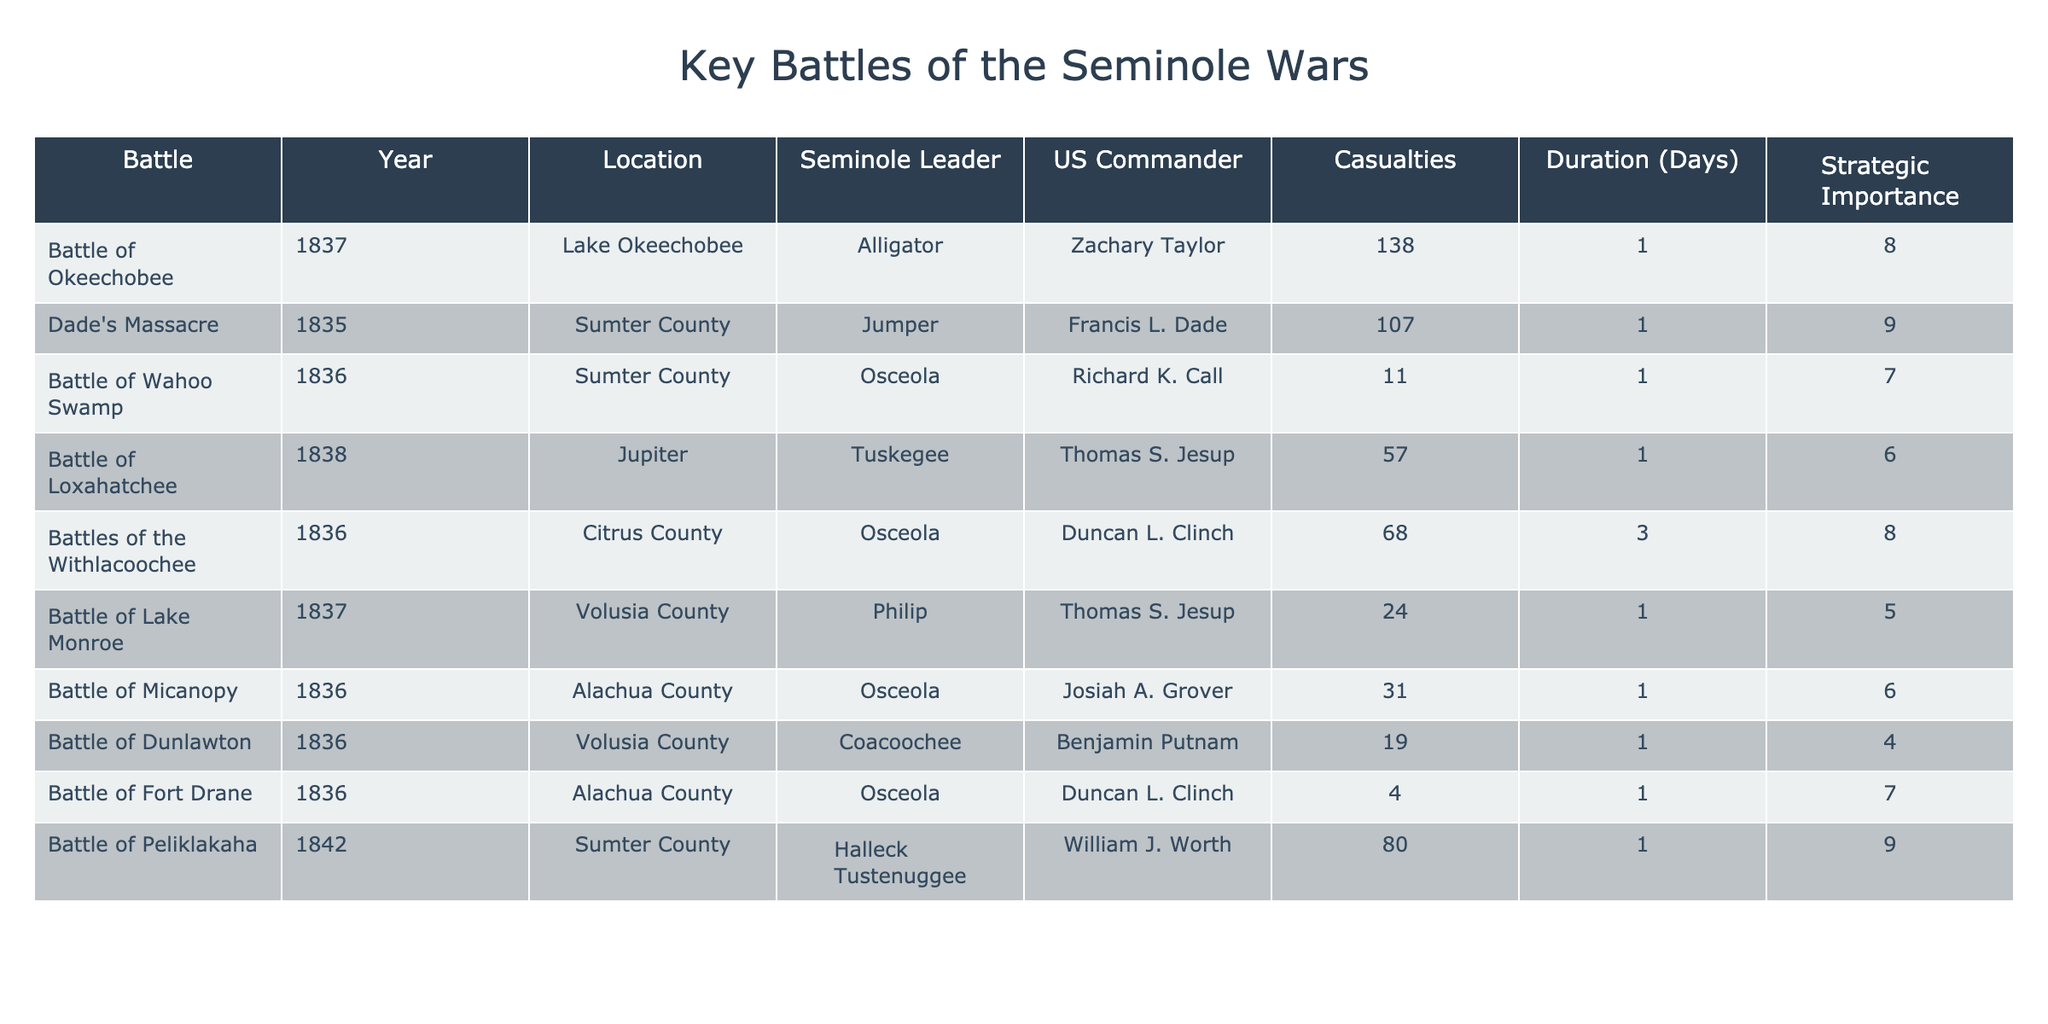What was the year of the Battle of Okeechobee? The table lists the Battle of Okeechobee under the column "Year" with the year specified as 1837.
Answer: 1837 Who was the US Commander at Dade's Massacre? By checking the table, I can see that the US Commander listed for Dade's Massacre is Francis L. Dade.
Answer: Francis L. Dade What was the location of the Battle of Loxahatchee? The table provides the location for the Battle of Loxahatchee, which is listed as Jupiter.
Answer: Jupiter How many casualties were reported in the Battle of Peliklakaha? Referring to the table, the Battle of Peliklakaha shows a casualty count of 80.
Answer: 80 Which battle had the longest duration? Comparing the "Duration" column in the table, the Battles of the Withlacoochee had the longest duration of 3 days.
Answer: Battles of the Withlacoochee Is Osceola the leader in more than one battle? Reviewing the table, I note that Osceola is listed as the Seminole leader for the Battle of Wahoo Swamp, the Battle of Micanopy, and the Battle of Fort Drane, confirming that this statement is true.
Answer: Yes What is the average number of casualties in the battles listed? Calculating the average requires summing the casualties: 138 + 107 + 11 + 57 + 68 + 24 + 31 + 19 + 4 + 80 =  519. There are 10 battles, so the average is 519 / 10 = 51.9.
Answer: 51.9 What is the strategic importance of the Battle of Lake Monroe? According to the table, the strategic importance for the Battle of Lake Monroe is given as 5.
Answer: 5 Which battle had the fewest casualties, and what was the number? Looking through the "Casualties" column, the Battle of Fort Drane has the fewest casualties at 4.
Answer: Battle of Fort Drane, 4 Compare the strategic importance of the Battle of Okeechobee to that of the Battle of Loxahatchee. The strategic importance for the Battle of Okeechobee is noted as 8, while for the Battle of Loxahatchee, it is listed as 6. This indicates that the Battle of Okeechobee had a higher strategic importance than the Battle of Loxahatchee.
Answer: Okeechobee had higher strategic importance 